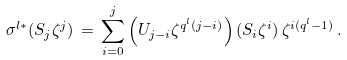<formula> <loc_0><loc_0><loc_500><loc_500>\sigma ^ { l \ast } ( S _ { j } \zeta ^ { j } ) \, = \, \sum _ { i = 0 } ^ { j } \left ( U _ { j - i } \zeta ^ { q ^ { l } ( j - i ) } \right ) ( S _ { i } \zeta ^ { i } ) \, \zeta ^ { i ( q ^ { l } - 1 ) } \, .</formula> 